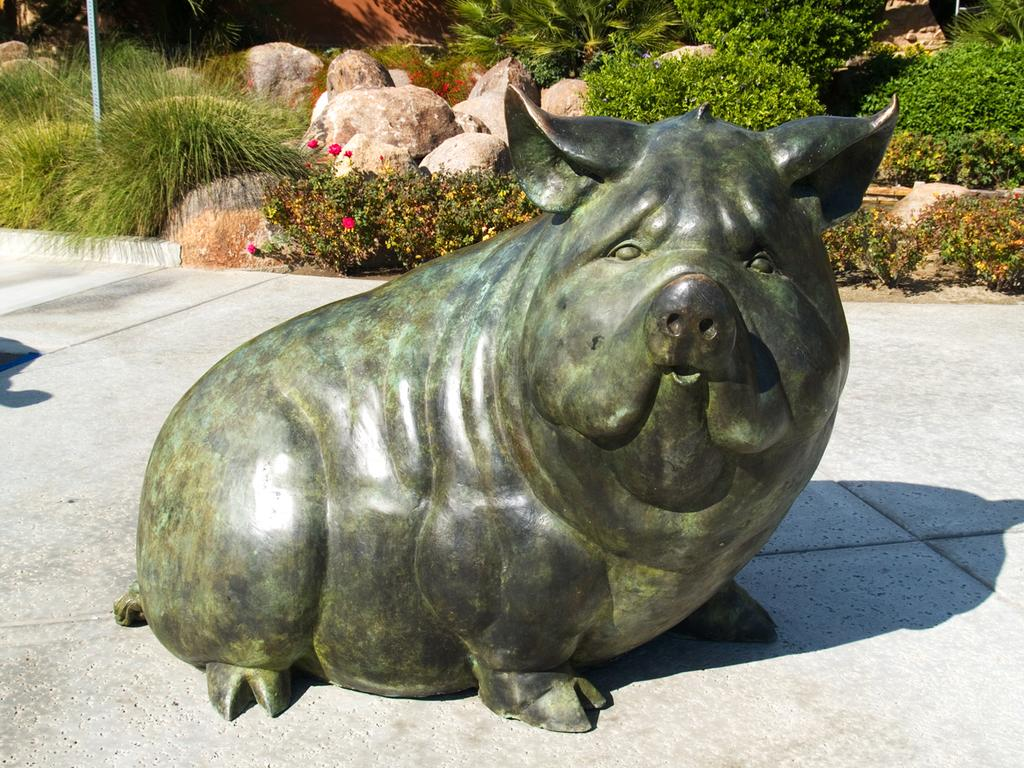What is the main subject of the image? There is a sculpture in the image. Where is the sculpture located? The sculpture is placed on the floor. What other elements can be seen in the image? There are flowers, plants, and rocks in the image. How many cobwebs are present in the image? There are no cobwebs present in the image. 